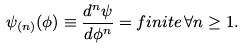Convert formula to latex. <formula><loc_0><loc_0><loc_500><loc_500>\psi _ { ( n ) } ( \phi ) \equiv \frac { d ^ { n } \psi } { d \phi ^ { n } } = f i n i t e \, \forall n \geq 1 .</formula> 